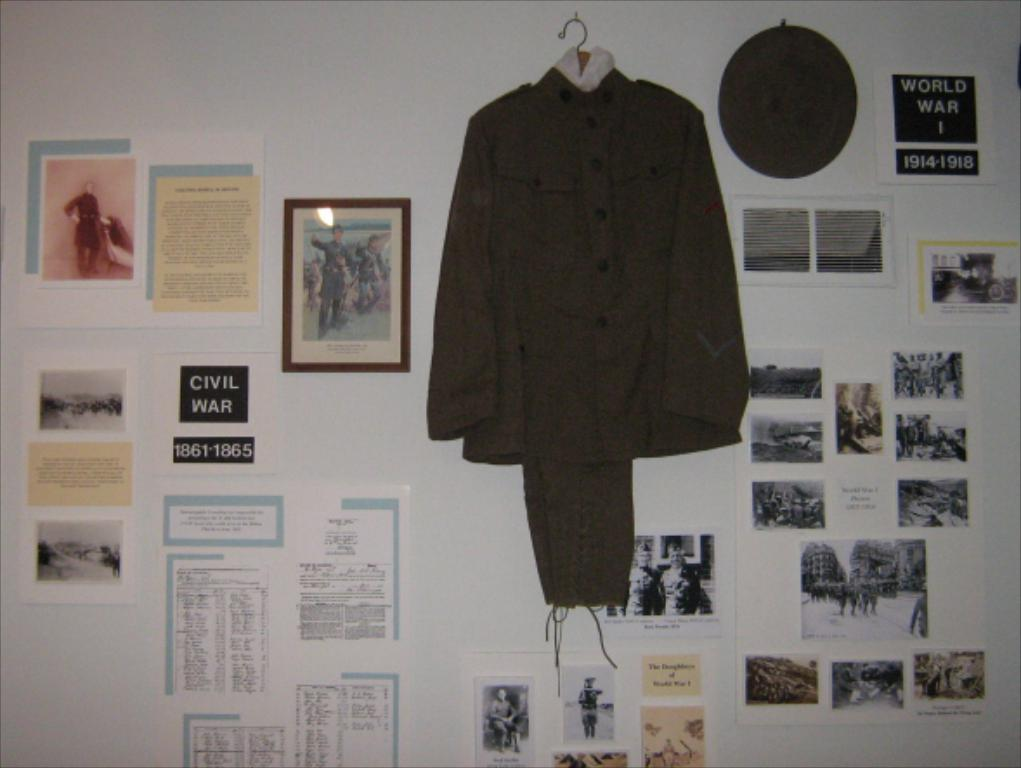What color is the wall in the image? The wall in the image is white. What is hanging on the wall? There are pictures and a dress on the wall. Can you describe the writing in the image? There is writing on both the left and right sides of the image. How does the stomach of the person in the image feel? There is no person present in the image, so it is not possible to determine how their stomach feels. 